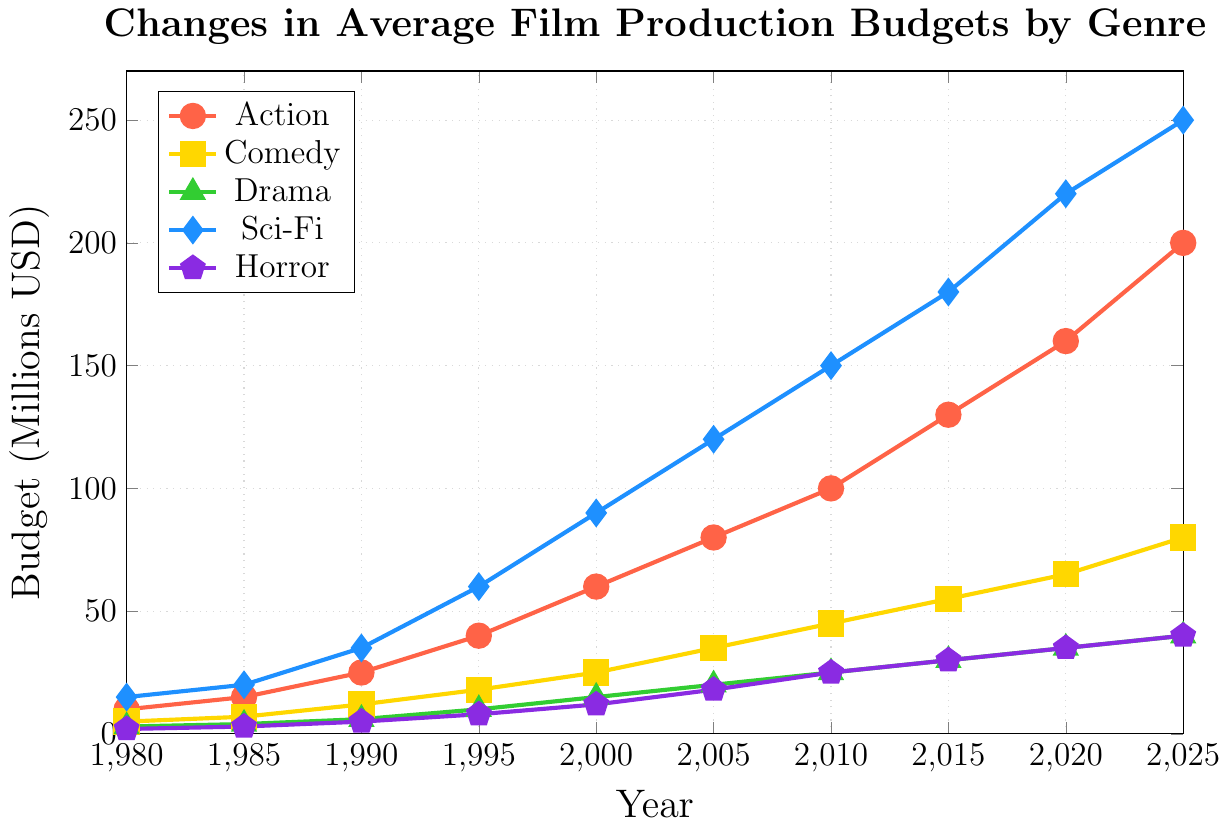What's the trend in budget for Sci-Fi films from 1980 to 2025? Observing the Sci-Fi line (blue diamond points), we can see that the budget has consistently increased over the years, starting from $15 million in 1980 to $250 million in 2025.
Answer: Consistent Increase Which genre had the highest average production budget in 2020? Looking at the 2020 data point on the x-axis, the Sci-Fi genre has the highest budget at $220 million compared to the other genres.
Answer: Sci-Fi By how much did the Comedy film budget increase between 1980 and 2025? The Comedy budget in 1980 was $5 million, and in 2025 it was $80 million. The increase is calculated as $80 million - $5 million = $75 million.
Answer: $75 million Which genre shows the least change in budget over the given time period? From the figure, the Horror genre (purple pentagon points) shows the least dramatic increase, going from $2 million in 1980 to $40 million in 2025.
Answer: Horror By what factor did the Horror film budget increase from 1980 to 2000? The Horror budget increased from $2 million in 1980 to $12 million in 2000. The factor is calculated as $12 million / $2 million = 6.
Answer: 6 Did the budget for Drama films ever exceed that of Comedy films? By comparing the Drama (green triangles) and Comedy (yellow squares) lines, the Drama budget does not exceed the Comedy budget at any point from 1980 to 2025.
Answer: No In which year did Action films surpass the $100 million budget mark? Inspecting the Action line (red circles), we find that the budget surpasses $100 million in 2010, where the budget is exactly $100 million.
Answer: 2010 Which genre had the fastest rate of budget increase during 1990 to 2000? Comparing the slopes of the lines between 1990 to 2000, Sci-Fi (blue diamonds) shows the steepest increase going from $35 million to $90 million.
Answer: Sci-Fi What is the difference in budget for Action and Drama films in 2025? The Action budget in 2025 is $200 million, while the Drama budget is $40 million. The difference is $200 million - $40 million = $160 million.
Answer: $160 million Compare the budget trends of Comedy and Horror films from 2005 to 2020. The Comedy budget increases more sharply from $35 million in 2005 to $65 million in 2020. The Horror budget rises from $18 million to $35 million in the same period, showing a more gradual increase.
Answer: Comedy increases more sharply 